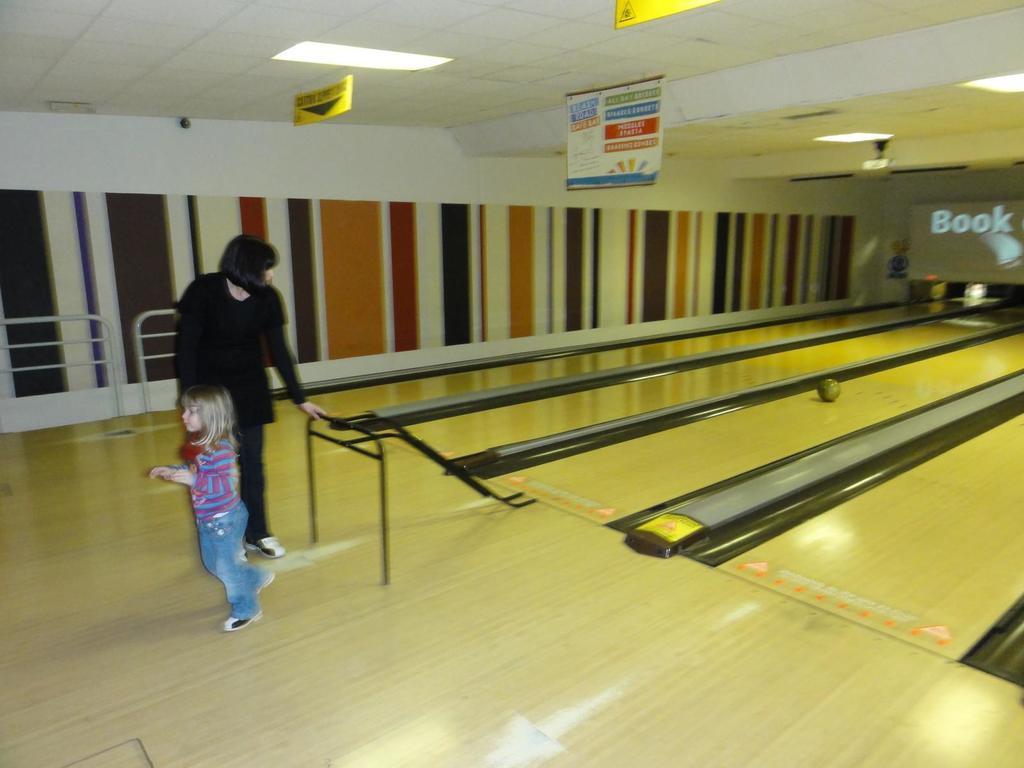Can you describe this image briefly? In this image I can see a person standing and wearing black color dress. In front the other person is wearing blue and pink color shirt and blue color pant. Background I can see a multi color wall and I can see few boards hanged to the wall. 